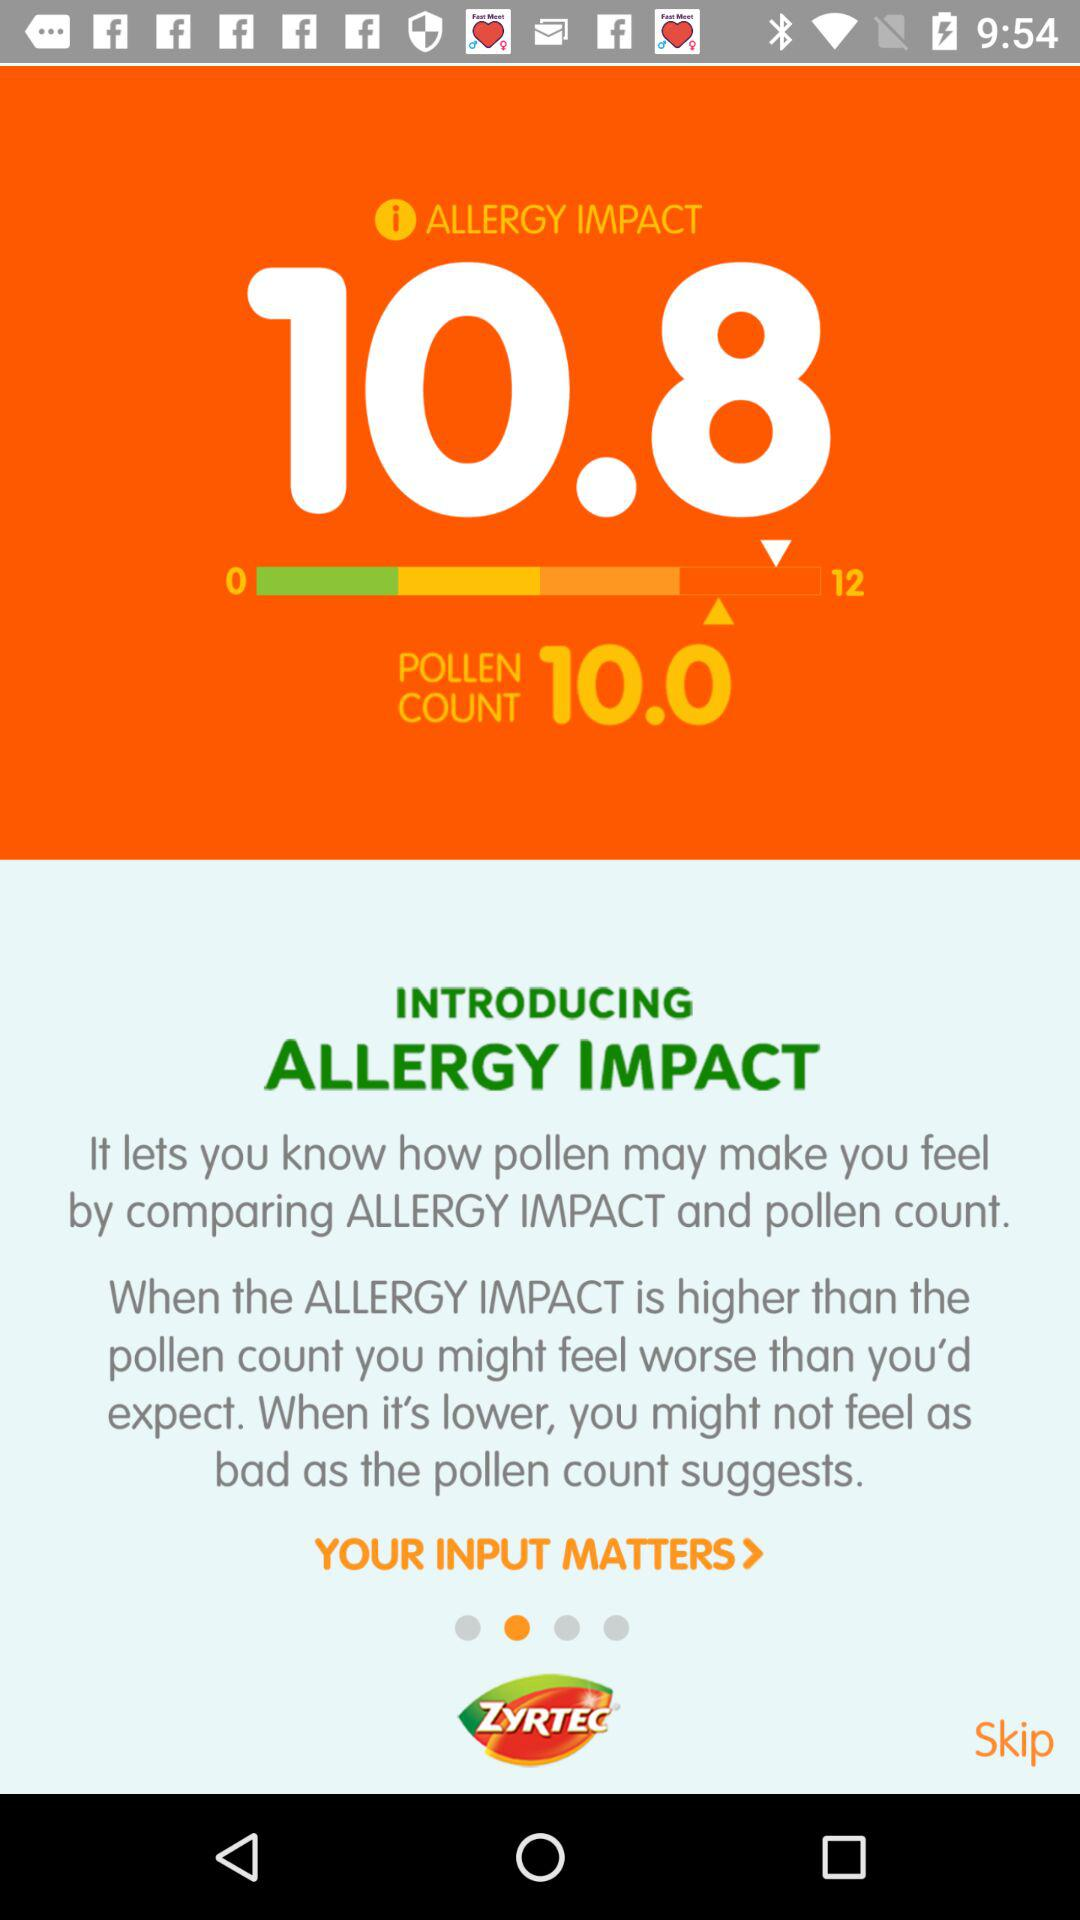What's the pollen count? The pollen count is 10. 